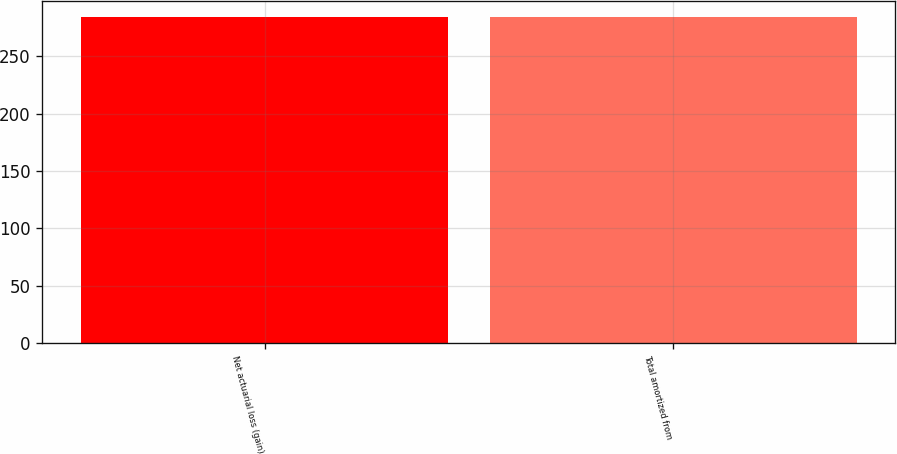Convert chart. <chart><loc_0><loc_0><loc_500><loc_500><bar_chart><fcel>Net actuarial loss (gain)<fcel>Total amortized from<nl><fcel>284<fcel>284.1<nl></chart> 